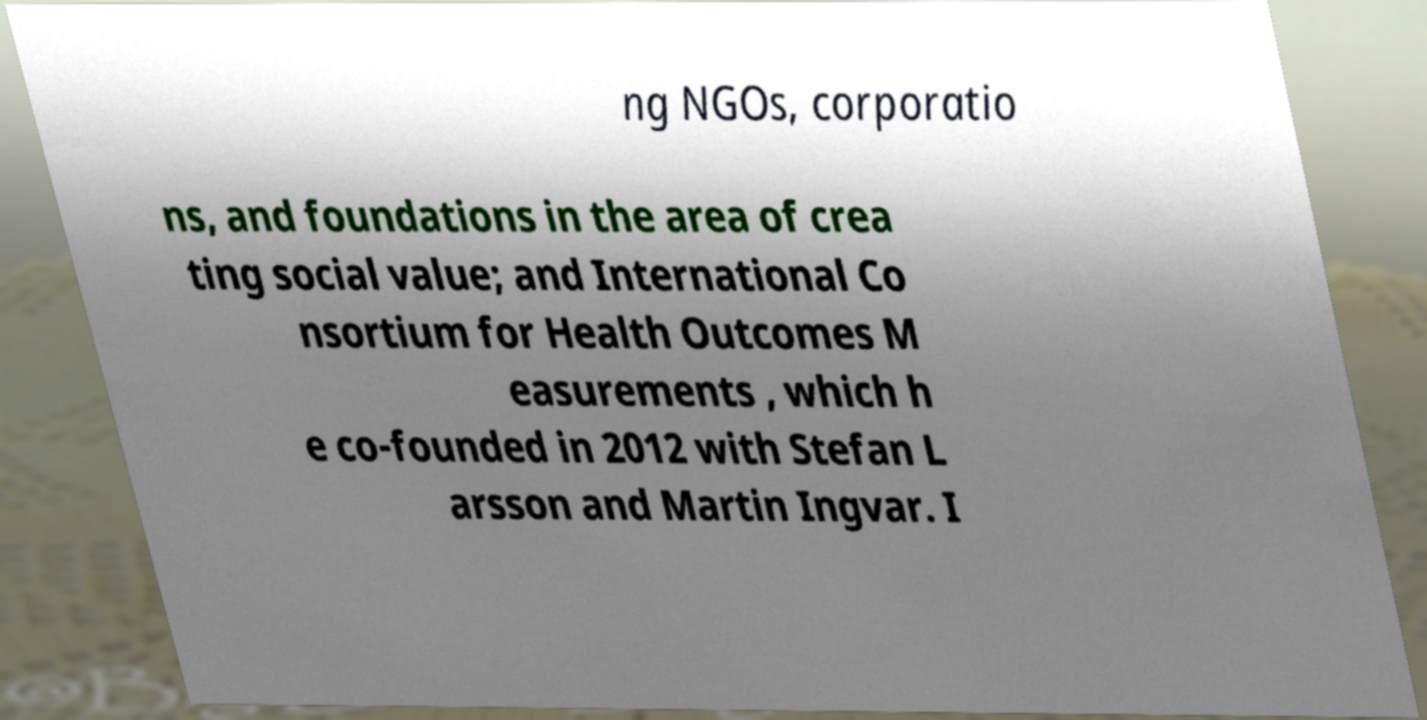For documentation purposes, I need the text within this image transcribed. Could you provide that? ng NGOs, corporatio ns, and foundations in the area of crea ting social value; and International Co nsortium for Health Outcomes M easurements , which h e co-founded in 2012 with Stefan L arsson and Martin Ingvar. I 